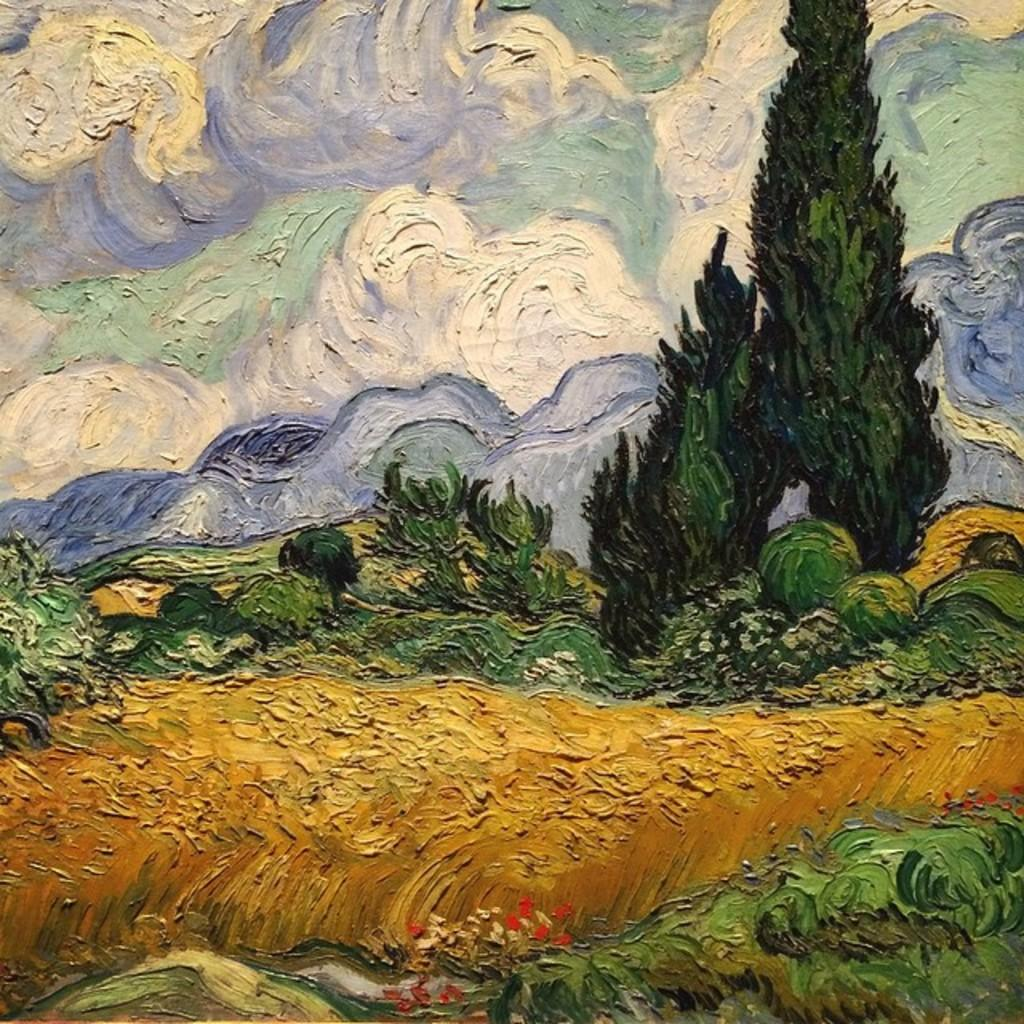What type of artwork is depicted in the image? The image is a painting. What type of natural environment is shown in the painting? There is grass, trees, and flowers in the painting. What color are the flowers in the painting? The flowers in the painting are red in color. What colors are present in the background of the painting? The background of the painting has white, green, and blue colors. What type of punishment is being administered to the flowers in the painting? There is no punishment being administered to the flowers in the painting; they are simply depicted as red flowers in the natural environment. How many eggs are visible in the painting? There are no eggs present in the painting; it features a natural environment with grass, trees, and flowers. 